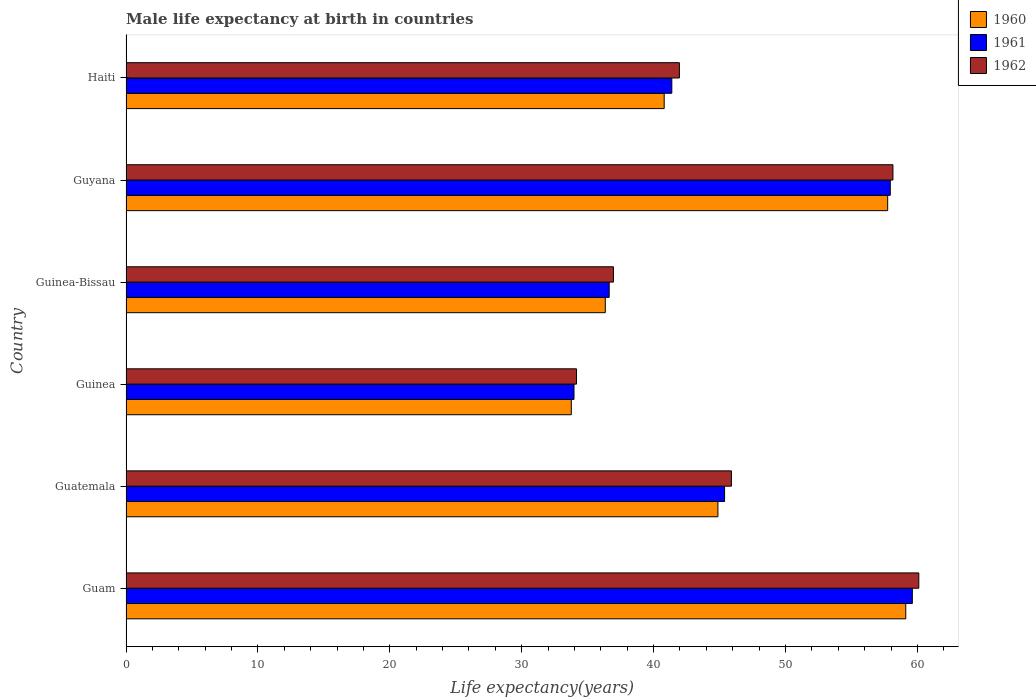Are the number of bars on each tick of the Y-axis equal?
Ensure brevity in your answer.  Yes. What is the label of the 3rd group of bars from the top?
Your response must be concise. Guinea-Bissau. What is the male life expectancy at birth in 1962 in Guatemala?
Make the answer very short. 45.9. Across all countries, what is the maximum male life expectancy at birth in 1960?
Offer a terse response. 59.12. Across all countries, what is the minimum male life expectancy at birth in 1960?
Your response must be concise. 33.76. In which country was the male life expectancy at birth in 1962 maximum?
Your answer should be very brief. Guam. In which country was the male life expectancy at birth in 1961 minimum?
Make the answer very short. Guinea. What is the total male life expectancy at birth in 1962 in the graph?
Offer a very short reply. 277.22. What is the difference between the male life expectancy at birth in 1962 in Guatemala and that in Guinea-Bissau?
Your response must be concise. 8.94. What is the difference between the male life expectancy at birth in 1962 in Guyana and the male life expectancy at birth in 1961 in Guinea-Bissau?
Give a very brief answer. 21.51. What is the average male life expectancy at birth in 1962 per country?
Provide a succinct answer. 46.2. What is the difference between the male life expectancy at birth in 1961 and male life expectancy at birth in 1962 in Guam?
Offer a very short reply. -0.49. In how many countries, is the male life expectancy at birth in 1962 greater than 12 years?
Keep it short and to the point. 6. What is the ratio of the male life expectancy at birth in 1962 in Guinea to that in Guyana?
Keep it short and to the point. 0.59. Is the male life expectancy at birth in 1961 in Guinea less than that in Guyana?
Your answer should be compact. Yes. Is the difference between the male life expectancy at birth in 1961 in Guatemala and Guinea greater than the difference between the male life expectancy at birth in 1962 in Guatemala and Guinea?
Your response must be concise. No. What is the difference between the highest and the second highest male life expectancy at birth in 1960?
Your answer should be compact. 1.37. What is the difference between the highest and the lowest male life expectancy at birth in 1961?
Your response must be concise. 25.65. In how many countries, is the male life expectancy at birth in 1961 greater than the average male life expectancy at birth in 1961 taken over all countries?
Give a very brief answer. 2. Is the sum of the male life expectancy at birth in 1960 in Guam and Guinea-Bissau greater than the maximum male life expectancy at birth in 1962 across all countries?
Your answer should be very brief. Yes. What does the 1st bar from the bottom in Haiti represents?
Keep it short and to the point. 1960. Is it the case that in every country, the sum of the male life expectancy at birth in 1962 and male life expectancy at birth in 1961 is greater than the male life expectancy at birth in 1960?
Keep it short and to the point. Yes. Are all the bars in the graph horizontal?
Your response must be concise. Yes. What is the difference between two consecutive major ticks on the X-axis?
Ensure brevity in your answer.  10. Are the values on the major ticks of X-axis written in scientific E-notation?
Provide a short and direct response. No. Does the graph contain grids?
Your response must be concise. No. What is the title of the graph?
Offer a terse response. Male life expectancy at birth in countries. Does "2002" appear as one of the legend labels in the graph?
Offer a very short reply. No. What is the label or title of the X-axis?
Make the answer very short. Life expectancy(years). What is the Life expectancy(years) of 1960 in Guam?
Provide a succinct answer. 59.12. What is the Life expectancy(years) of 1961 in Guam?
Keep it short and to the point. 59.62. What is the Life expectancy(years) in 1962 in Guam?
Provide a short and direct response. 60.11. What is the Life expectancy(years) in 1960 in Guatemala?
Ensure brevity in your answer.  44.88. What is the Life expectancy(years) of 1961 in Guatemala?
Provide a short and direct response. 45.38. What is the Life expectancy(years) in 1962 in Guatemala?
Ensure brevity in your answer.  45.9. What is the Life expectancy(years) in 1960 in Guinea?
Offer a very short reply. 33.76. What is the Life expectancy(years) of 1961 in Guinea?
Make the answer very short. 33.97. What is the Life expectancy(years) in 1962 in Guinea?
Make the answer very short. 34.16. What is the Life expectancy(years) in 1960 in Guinea-Bissau?
Keep it short and to the point. 36.34. What is the Life expectancy(years) in 1961 in Guinea-Bissau?
Offer a terse response. 36.63. What is the Life expectancy(years) of 1962 in Guinea-Bissau?
Provide a short and direct response. 36.96. What is the Life expectancy(years) of 1960 in Guyana?
Offer a terse response. 57.75. What is the Life expectancy(years) of 1961 in Guyana?
Keep it short and to the point. 57.95. What is the Life expectancy(years) in 1962 in Guyana?
Give a very brief answer. 58.15. What is the Life expectancy(years) of 1960 in Haiti?
Provide a succinct answer. 40.8. What is the Life expectancy(years) in 1961 in Haiti?
Your answer should be compact. 41.38. What is the Life expectancy(years) of 1962 in Haiti?
Provide a succinct answer. 41.96. Across all countries, what is the maximum Life expectancy(years) of 1960?
Ensure brevity in your answer.  59.12. Across all countries, what is the maximum Life expectancy(years) of 1961?
Offer a terse response. 59.62. Across all countries, what is the maximum Life expectancy(years) of 1962?
Provide a succinct answer. 60.11. Across all countries, what is the minimum Life expectancy(years) of 1960?
Offer a very short reply. 33.76. Across all countries, what is the minimum Life expectancy(years) of 1961?
Your answer should be compact. 33.97. Across all countries, what is the minimum Life expectancy(years) in 1962?
Ensure brevity in your answer.  34.16. What is the total Life expectancy(years) in 1960 in the graph?
Your response must be concise. 272.65. What is the total Life expectancy(years) of 1961 in the graph?
Provide a succinct answer. 274.93. What is the total Life expectancy(years) in 1962 in the graph?
Your answer should be compact. 277.22. What is the difference between the Life expectancy(years) in 1960 in Guam and that in Guatemala?
Your answer should be very brief. 14.24. What is the difference between the Life expectancy(years) in 1961 in Guam and that in Guatemala?
Your answer should be compact. 14.23. What is the difference between the Life expectancy(years) in 1962 in Guam and that in Guatemala?
Your answer should be very brief. 14.21. What is the difference between the Life expectancy(years) in 1960 in Guam and that in Guinea?
Provide a short and direct response. 25.36. What is the difference between the Life expectancy(years) of 1961 in Guam and that in Guinea?
Your response must be concise. 25.65. What is the difference between the Life expectancy(years) of 1962 in Guam and that in Guinea?
Offer a very short reply. 25.95. What is the difference between the Life expectancy(years) in 1960 in Guam and that in Guinea-Bissau?
Keep it short and to the point. 22.78. What is the difference between the Life expectancy(years) in 1961 in Guam and that in Guinea-Bissau?
Offer a very short reply. 22.98. What is the difference between the Life expectancy(years) in 1962 in Guam and that in Guinea-Bissau?
Keep it short and to the point. 23.15. What is the difference between the Life expectancy(years) of 1960 in Guam and that in Guyana?
Provide a short and direct response. 1.37. What is the difference between the Life expectancy(years) in 1961 in Guam and that in Guyana?
Your answer should be very brief. 1.67. What is the difference between the Life expectancy(years) of 1962 in Guam and that in Guyana?
Your answer should be very brief. 1.96. What is the difference between the Life expectancy(years) in 1960 in Guam and that in Haiti?
Give a very brief answer. 18.32. What is the difference between the Life expectancy(years) of 1961 in Guam and that in Haiti?
Offer a terse response. 18.23. What is the difference between the Life expectancy(years) in 1962 in Guam and that in Haiti?
Give a very brief answer. 18.15. What is the difference between the Life expectancy(years) of 1960 in Guatemala and that in Guinea?
Provide a short and direct response. 11.12. What is the difference between the Life expectancy(years) in 1961 in Guatemala and that in Guinea?
Keep it short and to the point. 11.42. What is the difference between the Life expectancy(years) in 1962 in Guatemala and that in Guinea?
Ensure brevity in your answer.  11.74. What is the difference between the Life expectancy(years) of 1960 in Guatemala and that in Guinea-Bissau?
Provide a succinct answer. 8.54. What is the difference between the Life expectancy(years) in 1961 in Guatemala and that in Guinea-Bissau?
Give a very brief answer. 8.75. What is the difference between the Life expectancy(years) of 1962 in Guatemala and that in Guinea-Bissau?
Provide a succinct answer. 8.94. What is the difference between the Life expectancy(years) of 1960 in Guatemala and that in Guyana?
Provide a succinct answer. -12.87. What is the difference between the Life expectancy(years) in 1961 in Guatemala and that in Guyana?
Offer a very short reply. -12.56. What is the difference between the Life expectancy(years) in 1962 in Guatemala and that in Guyana?
Your answer should be very brief. -12.25. What is the difference between the Life expectancy(years) of 1960 in Guatemala and that in Haiti?
Ensure brevity in your answer.  4.07. What is the difference between the Life expectancy(years) of 1962 in Guatemala and that in Haiti?
Your response must be concise. 3.94. What is the difference between the Life expectancy(years) in 1960 in Guinea and that in Guinea-Bissau?
Give a very brief answer. -2.58. What is the difference between the Life expectancy(years) in 1961 in Guinea and that in Guinea-Bissau?
Ensure brevity in your answer.  -2.67. What is the difference between the Life expectancy(years) of 1962 in Guinea and that in Guinea-Bissau?
Your answer should be compact. -2.8. What is the difference between the Life expectancy(years) of 1960 in Guinea and that in Guyana?
Offer a very short reply. -23.99. What is the difference between the Life expectancy(years) in 1961 in Guinea and that in Guyana?
Your response must be concise. -23.98. What is the difference between the Life expectancy(years) of 1962 in Guinea and that in Guyana?
Offer a very short reply. -23.99. What is the difference between the Life expectancy(years) in 1960 in Guinea and that in Haiti?
Provide a succinct answer. -7.04. What is the difference between the Life expectancy(years) of 1961 in Guinea and that in Haiti?
Your answer should be compact. -7.42. What is the difference between the Life expectancy(years) in 1960 in Guinea-Bissau and that in Guyana?
Ensure brevity in your answer.  -21.41. What is the difference between the Life expectancy(years) of 1961 in Guinea-Bissau and that in Guyana?
Keep it short and to the point. -21.31. What is the difference between the Life expectancy(years) of 1962 in Guinea-Bissau and that in Guyana?
Your answer should be very brief. -21.19. What is the difference between the Life expectancy(years) in 1960 in Guinea-Bissau and that in Haiti?
Keep it short and to the point. -4.47. What is the difference between the Life expectancy(years) in 1961 in Guinea-Bissau and that in Haiti?
Your answer should be very brief. -4.75. What is the difference between the Life expectancy(years) in 1962 in Guinea-Bissau and that in Haiti?
Give a very brief answer. -5. What is the difference between the Life expectancy(years) of 1960 in Guyana and that in Haiti?
Provide a succinct answer. 16.94. What is the difference between the Life expectancy(years) of 1961 in Guyana and that in Haiti?
Provide a succinct answer. 16.56. What is the difference between the Life expectancy(years) of 1962 in Guyana and that in Haiti?
Give a very brief answer. 16.19. What is the difference between the Life expectancy(years) in 1960 in Guam and the Life expectancy(years) in 1961 in Guatemala?
Offer a very short reply. 13.74. What is the difference between the Life expectancy(years) of 1960 in Guam and the Life expectancy(years) of 1962 in Guatemala?
Give a very brief answer. 13.22. What is the difference between the Life expectancy(years) in 1961 in Guam and the Life expectancy(years) in 1962 in Guatemala?
Provide a short and direct response. 13.72. What is the difference between the Life expectancy(years) in 1960 in Guam and the Life expectancy(years) in 1961 in Guinea?
Ensure brevity in your answer.  25.15. What is the difference between the Life expectancy(years) of 1960 in Guam and the Life expectancy(years) of 1962 in Guinea?
Ensure brevity in your answer.  24.96. What is the difference between the Life expectancy(years) in 1961 in Guam and the Life expectancy(years) in 1962 in Guinea?
Give a very brief answer. 25.46. What is the difference between the Life expectancy(years) in 1960 in Guam and the Life expectancy(years) in 1961 in Guinea-Bissau?
Offer a very short reply. 22.48. What is the difference between the Life expectancy(years) of 1960 in Guam and the Life expectancy(years) of 1962 in Guinea-Bissau?
Keep it short and to the point. 22.16. What is the difference between the Life expectancy(years) of 1961 in Guam and the Life expectancy(years) of 1962 in Guinea-Bissau?
Provide a succinct answer. 22.66. What is the difference between the Life expectancy(years) of 1960 in Guam and the Life expectancy(years) of 1961 in Guyana?
Offer a very short reply. 1.17. What is the difference between the Life expectancy(years) in 1961 in Guam and the Life expectancy(years) in 1962 in Guyana?
Provide a short and direct response. 1.47. What is the difference between the Life expectancy(years) in 1960 in Guam and the Life expectancy(years) in 1961 in Haiti?
Your response must be concise. 17.74. What is the difference between the Life expectancy(years) of 1960 in Guam and the Life expectancy(years) of 1962 in Haiti?
Offer a terse response. 17.16. What is the difference between the Life expectancy(years) of 1961 in Guam and the Life expectancy(years) of 1962 in Haiti?
Provide a succinct answer. 17.66. What is the difference between the Life expectancy(years) in 1960 in Guatemala and the Life expectancy(years) in 1961 in Guinea?
Make the answer very short. 10.91. What is the difference between the Life expectancy(years) of 1960 in Guatemala and the Life expectancy(years) of 1962 in Guinea?
Your response must be concise. 10.72. What is the difference between the Life expectancy(years) of 1961 in Guatemala and the Life expectancy(years) of 1962 in Guinea?
Give a very brief answer. 11.23. What is the difference between the Life expectancy(years) of 1960 in Guatemala and the Life expectancy(years) of 1961 in Guinea-Bissau?
Provide a short and direct response. 8.24. What is the difference between the Life expectancy(years) of 1960 in Guatemala and the Life expectancy(years) of 1962 in Guinea-Bissau?
Provide a short and direct response. 7.92. What is the difference between the Life expectancy(years) of 1961 in Guatemala and the Life expectancy(years) of 1962 in Guinea-Bissau?
Ensure brevity in your answer.  8.43. What is the difference between the Life expectancy(years) in 1960 in Guatemala and the Life expectancy(years) in 1961 in Guyana?
Your answer should be compact. -13.07. What is the difference between the Life expectancy(years) in 1960 in Guatemala and the Life expectancy(years) in 1962 in Guyana?
Your answer should be compact. -13.27. What is the difference between the Life expectancy(years) of 1961 in Guatemala and the Life expectancy(years) of 1962 in Guyana?
Your response must be concise. -12.77. What is the difference between the Life expectancy(years) of 1960 in Guatemala and the Life expectancy(years) of 1961 in Haiti?
Make the answer very short. 3.5. What is the difference between the Life expectancy(years) of 1960 in Guatemala and the Life expectancy(years) of 1962 in Haiti?
Offer a very short reply. 2.92. What is the difference between the Life expectancy(years) in 1961 in Guatemala and the Life expectancy(years) in 1962 in Haiti?
Provide a short and direct response. 3.43. What is the difference between the Life expectancy(years) of 1960 in Guinea and the Life expectancy(years) of 1961 in Guinea-Bissau?
Your response must be concise. -2.87. What is the difference between the Life expectancy(years) in 1960 in Guinea and the Life expectancy(years) in 1962 in Guinea-Bissau?
Your answer should be compact. -3.19. What is the difference between the Life expectancy(years) in 1961 in Guinea and the Life expectancy(years) in 1962 in Guinea-Bissau?
Provide a succinct answer. -2.99. What is the difference between the Life expectancy(years) in 1960 in Guinea and the Life expectancy(years) in 1961 in Guyana?
Give a very brief answer. -24.18. What is the difference between the Life expectancy(years) of 1960 in Guinea and the Life expectancy(years) of 1962 in Guyana?
Your answer should be very brief. -24.39. What is the difference between the Life expectancy(years) in 1961 in Guinea and the Life expectancy(years) in 1962 in Guyana?
Give a very brief answer. -24.18. What is the difference between the Life expectancy(years) in 1960 in Guinea and the Life expectancy(years) in 1961 in Haiti?
Your response must be concise. -7.62. What is the difference between the Life expectancy(years) in 1960 in Guinea and the Life expectancy(years) in 1962 in Haiti?
Provide a succinct answer. -8.19. What is the difference between the Life expectancy(years) in 1961 in Guinea and the Life expectancy(years) in 1962 in Haiti?
Provide a succinct answer. -7.99. What is the difference between the Life expectancy(years) of 1960 in Guinea-Bissau and the Life expectancy(years) of 1961 in Guyana?
Give a very brief answer. -21.61. What is the difference between the Life expectancy(years) of 1960 in Guinea-Bissau and the Life expectancy(years) of 1962 in Guyana?
Your response must be concise. -21.81. What is the difference between the Life expectancy(years) of 1961 in Guinea-Bissau and the Life expectancy(years) of 1962 in Guyana?
Offer a very short reply. -21.51. What is the difference between the Life expectancy(years) of 1960 in Guinea-Bissau and the Life expectancy(years) of 1961 in Haiti?
Make the answer very short. -5.04. What is the difference between the Life expectancy(years) of 1960 in Guinea-Bissau and the Life expectancy(years) of 1962 in Haiti?
Make the answer very short. -5.62. What is the difference between the Life expectancy(years) in 1961 in Guinea-Bissau and the Life expectancy(years) in 1962 in Haiti?
Your response must be concise. -5.32. What is the difference between the Life expectancy(years) in 1960 in Guyana and the Life expectancy(years) in 1961 in Haiti?
Make the answer very short. 16.37. What is the difference between the Life expectancy(years) of 1960 in Guyana and the Life expectancy(years) of 1962 in Haiti?
Provide a short and direct response. 15.79. What is the difference between the Life expectancy(years) of 1961 in Guyana and the Life expectancy(years) of 1962 in Haiti?
Provide a short and direct response. 15.99. What is the average Life expectancy(years) of 1960 per country?
Give a very brief answer. 45.44. What is the average Life expectancy(years) of 1961 per country?
Give a very brief answer. 45.82. What is the average Life expectancy(years) of 1962 per country?
Offer a terse response. 46.2. What is the difference between the Life expectancy(years) in 1960 and Life expectancy(years) in 1961 in Guam?
Offer a terse response. -0.5. What is the difference between the Life expectancy(years) of 1960 and Life expectancy(years) of 1962 in Guam?
Provide a succinct answer. -0.99. What is the difference between the Life expectancy(years) in 1961 and Life expectancy(years) in 1962 in Guam?
Provide a succinct answer. -0.49. What is the difference between the Life expectancy(years) in 1960 and Life expectancy(years) in 1961 in Guatemala?
Offer a very short reply. -0.51. What is the difference between the Life expectancy(years) in 1960 and Life expectancy(years) in 1962 in Guatemala?
Your answer should be compact. -1.02. What is the difference between the Life expectancy(years) of 1961 and Life expectancy(years) of 1962 in Guatemala?
Give a very brief answer. -0.52. What is the difference between the Life expectancy(years) of 1960 and Life expectancy(years) of 1961 in Guinea?
Make the answer very short. -0.2. What is the difference between the Life expectancy(years) of 1960 and Life expectancy(years) of 1962 in Guinea?
Your answer should be compact. -0.39. What is the difference between the Life expectancy(years) in 1961 and Life expectancy(years) in 1962 in Guinea?
Provide a short and direct response. -0.19. What is the difference between the Life expectancy(years) in 1960 and Life expectancy(years) in 1961 in Guinea-Bissau?
Provide a succinct answer. -0.3. What is the difference between the Life expectancy(years) of 1960 and Life expectancy(years) of 1962 in Guinea-Bissau?
Offer a terse response. -0.62. What is the difference between the Life expectancy(years) of 1961 and Life expectancy(years) of 1962 in Guinea-Bissau?
Provide a succinct answer. -0.32. What is the difference between the Life expectancy(years) of 1960 and Life expectancy(years) of 1961 in Guyana?
Give a very brief answer. -0.2. What is the difference between the Life expectancy(years) in 1960 and Life expectancy(years) in 1962 in Guyana?
Your response must be concise. -0.4. What is the difference between the Life expectancy(years) of 1961 and Life expectancy(years) of 1962 in Guyana?
Your answer should be very brief. -0.2. What is the difference between the Life expectancy(years) of 1960 and Life expectancy(years) of 1961 in Haiti?
Offer a terse response. -0.58. What is the difference between the Life expectancy(years) in 1960 and Life expectancy(years) in 1962 in Haiti?
Offer a very short reply. -1.15. What is the difference between the Life expectancy(years) in 1961 and Life expectancy(years) in 1962 in Haiti?
Offer a terse response. -0.57. What is the ratio of the Life expectancy(years) of 1960 in Guam to that in Guatemala?
Your response must be concise. 1.32. What is the ratio of the Life expectancy(years) in 1961 in Guam to that in Guatemala?
Ensure brevity in your answer.  1.31. What is the ratio of the Life expectancy(years) of 1962 in Guam to that in Guatemala?
Keep it short and to the point. 1.31. What is the ratio of the Life expectancy(years) of 1960 in Guam to that in Guinea?
Make the answer very short. 1.75. What is the ratio of the Life expectancy(years) of 1961 in Guam to that in Guinea?
Provide a succinct answer. 1.76. What is the ratio of the Life expectancy(years) in 1962 in Guam to that in Guinea?
Provide a succinct answer. 1.76. What is the ratio of the Life expectancy(years) in 1960 in Guam to that in Guinea-Bissau?
Give a very brief answer. 1.63. What is the ratio of the Life expectancy(years) in 1961 in Guam to that in Guinea-Bissau?
Your response must be concise. 1.63. What is the ratio of the Life expectancy(years) in 1962 in Guam to that in Guinea-Bissau?
Your response must be concise. 1.63. What is the ratio of the Life expectancy(years) in 1960 in Guam to that in Guyana?
Ensure brevity in your answer.  1.02. What is the ratio of the Life expectancy(years) in 1961 in Guam to that in Guyana?
Provide a short and direct response. 1.03. What is the ratio of the Life expectancy(years) of 1962 in Guam to that in Guyana?
Make the answer very short. 1.03. What is the ratio of the Life expectancy(years) of 1960 in Guam to that in Haiti?
Offer a very short reply. 1.45. What is the ratio of the Life expectancy(years) in 1961 in Guam to that in Haiti?
Your response must be concise. 1.44. What is the ratio of the Life expectancy(years) in 1962 in Guam to that in Haiti?
Your answer should be compact. 1.43. What is the ratio of the Life expectancy(years) in 1960 in Guatemala to that in Guinea?
Offer a very short reply. 1.33. What is the ratio of the Life expectancy(years) in 1961 in Guatemala to that in Guinea?
Make the answer very short. 1.34. What is the ratio of the Life expectancy(years) of 1962 in Guatemala to that in Guinea?
Ensure brevity in your answer.  1.34. What is the ratio of the Life expectancy(years) in 1960 in Guatemala to that in Guinea-Bissau?
Give a very brief answer. 1.24. What is the ratio of the Life expectancy(years) in 1961 in Guatemala to that in Guinea-Bissau?
Provide a short and direct response. 1.24. What is the ratio of the Life expectancy(years) of 1962 in Guatemala to that in Guinea-Bissau?
Provide a succinct answer. 1.24. What is the ratio of the Life expectancy(years) of 1960 in Guatemala to that in Guyana?
Ensure brevity in your answer.  0.78. What is the ratio of the Life expectancy(years) of 1961 in Guatemala to that in Guyana?
Offer a very short reply. 0.78. What is the ratio of the Life expectancy(years) of 1962 in Guatemala to that in Guyana?
Offer a very short reply. 0.79. What is the ratio of the Life expectancy(years) in 1960 in Guatemala to that in Haiti?
Offer a very short reply. 1.1. What is the ratio of the Life expectancy(years) in 1961 in Guatemala to that in Haiti?
Keep it short and to the point. 1.1. What is the ratio of the Life expectancy(years) of 1962 in Guatemala to that in Haiti?
Provide a short and direct response. 1.09. What is the ratio of the Life expectancy(years) in 1960 in Guinea to that in Guinea-Bissau?
Offer a terse response. 0.93. What is the ratio of the Life expectancy(years) of 1961 in Guinea to that in Guinea-Bissau?
Ensure brevity in your answer.  0.93. What is the ratio of the Life expectancy(years) of 1962 in Guinea to that in Guinea-Bissau?
Offer a very short reply. 0.92. What is the ratio of the Life expectancy(years) in 1960 in Guinea to that in Guyana?
Your answer should be very brief. 0.58. What is the ratio of the Life expectancy(years) of 1961 in Guinea to that in Guyana?
Keep it short and to the point. 0.59. What is the ratio of the Life expectancy(years) of 1962 in Guinea to that in Guyana?
Keep it short and to the point. 0.59. What is the ratio of the Life expectancy(years) of 1960 in Guinea to that in Haiti?
Make the answer very short. 0.83. What is the ratio of the Life expectancy(years) in 1961 in Guinea to that in Haiti?
Your response must be concise. 0.82. What is the ratio of the Life expectancy(years) of 1962 in Guinea to that in Haiti?
Offer a very short reply. 0.81. What is the ratio of the Life expectancy(years) in 1960 in Guinea-Bissau to that in Guyana?
Offer a very short reply. 0.63. What is the ratio of the Life expectancy(years) in 1961 in Guinea-Bissau to that in Guyana?
Give a very brief answer. 0.63. What is the ratio of the Life expectancy(years) in 1962 in Guinea-Bissau to that in Guyana?
Give a very brief answer. 0.64. What is the ratio of the Life expectancy(years) of 1960 in Guinea-Bissau to that in Haiti?
Provide a succinct answer. 0.89. What is the ratio of the Life expectancy(years) of 1961 in Guinea-Bissau to that in Haiti?
Provide a succinct answer. 0.89. What is the ratio of the Life expectancy(years) in 1962 in Guinea-Bissau to that in Haiti?
Your answer should be compact. 0.88. What is the ratio of the Life expectancy(years) in 1960 in Guyana to that in Haiti?
Provide a succinct answer. 1.42. What is the ratio of the Life expectancy(years) in 1961 in Guyana to that in Haiti?
Provide a short and direct response. 1.4. What is the ratio of the Life expectancy(years) in 1962 in Guyana to that in Haiti?
Give a very brief answer. 1.39. What is the difference between the highest and the second highest Life expectancy(years) of 1960?
Provide a short and direct response. 1.37. What is the difference between the highest and the second highest Life expectancy(years) of 1961?
Offer a very short reply. 1.67. What is the difference between the highest and the second highest Life expectancy(years) of 1962?
Your response must be concise. 1.96. What is the difference between the highest and the lowest Life expectancy(years) in 1960?
Offer a terse response. 25.36. What is the difference between the highest and the lowest Life expectancy(years) of 1961?
Ensure brevity in your answer.  25.65. What is the difference between the highest and the lowest Life expectancy(years) of 1962?
Your answer should be very brief. 25.95. 